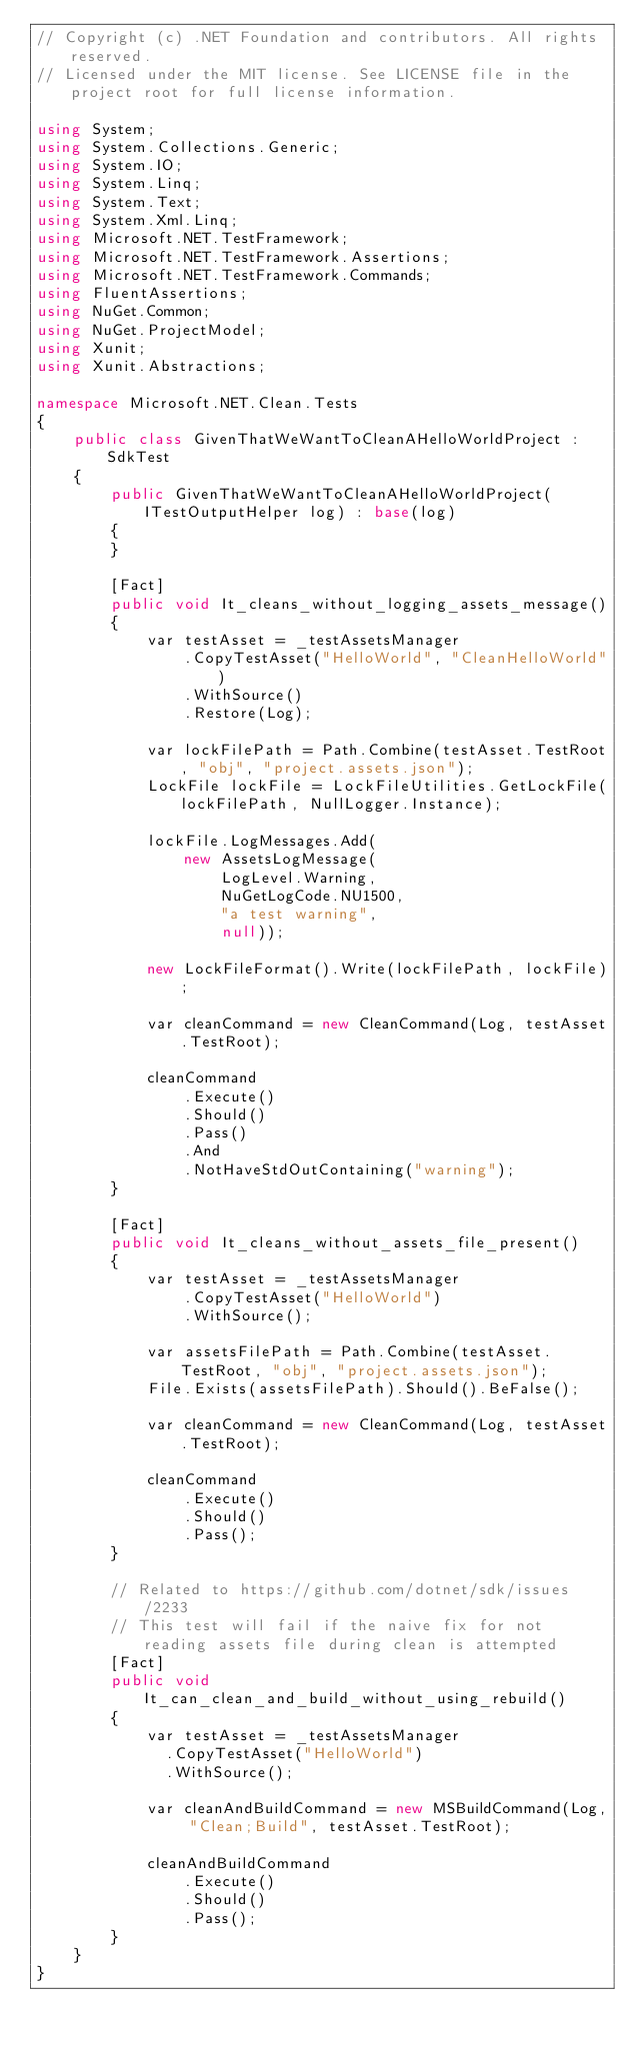Convert code to text. <code><loc_0><loc_0><loc_500><loc_500><_C#_>// Copyright (c) .NET Foundation and contributors. All rights reserved.
// Licensed under the MIT license. See LICENSE file in the project root for full license information.

using System;
using System.Collections.Generic;
using System.IO;
using System.Linq;
using System.Text;
using System.Xml.Linq;
using Microsoft.NET.TestFramework;
using Microsoft.NET.TestFramework.Assertions;
using Microsoft.NET.TestFramework.Commands;
using FluentAssertions;
using NuGet.Common;
using NuGet.ProjectModel;
using Xunit;
using Xunit.Abstractions;

namespace Microsoft.NET.Clean.Tests
{
    public class GivenThatWeWantToCleanAHelloWorldProject : SdkTest
    {
        public GivenThatWeWantToCleanAHelloWorldProject(ITestOutputHelper log) : base(log)
        {
        }

        [Fact]
        public void It_cleans_without_logging_assets_message()
        {
            var testAsset = _testAssetsManager
                .CopyTestAsset("HelloWorld", "CleanHelloWorld")
                .WithSource()
                .Restore(Log);

            var lockFilePath = Path.Combine(testAsset.TestRoot, "obj", "project.assets.json");
            LockFile lockFile = LockFileUtilities.GetLockFile(lockFilePath, NullLogger.Instance);

            lockFile.LogMessages.Add(
                new AssetsLogMessage(
                    LogLevel.Warning,
                    NuGetLogCode.NU1500,
                    "a test warning",
                    null));

            new LockFileFormat().Write(lockFilePath, lockFile);

            var cleanCommand = new CleanCommand(Log, testAsset.TestRoot);

            cleanCommand
                .Execute()
                .Should()
                .Pass()
                .And
                .NotHaveStdOutContaining("warning");
        }

        [Fact]
        public void It_cleans_without_assets_file_present()
        {
            var testAsset = _testAssetsManager
                .CopyTestAsset("HelloWorld")
                .WithSource();

            var assetsFilePath = Path.Combine(testAsset.TestRoot, "obj", "project.assets.json");
            File.Exists(assetsFilePath).Should().BeFalse();

            var cleanCommand = new CleanCommand(Log, testAsset.TestRoot);

            cleanCommand
                .Execute()
                .Should()
                .Pass();
        }

        // Related to https://github.com/dotnet/sdk/issues/2233
        // This test will fail if the naive fix for not reading assets file during clean is attempted
        [Fact]
        public void It_can_clean_and_build_without_using_rebuild()
        {
            var testAsset = _testAssetsManager
              .CopyTestAsset("HelloWorld")
              .WithSource();

            var cleanAndBuildCommand = new MSBuildCommand(Log, "Clean;Build", testAsset.TestRoot);

            cleanAndBuildCommand
                .Execute()
                .Should()
                .Pass();
        }
    }
}
</code> 